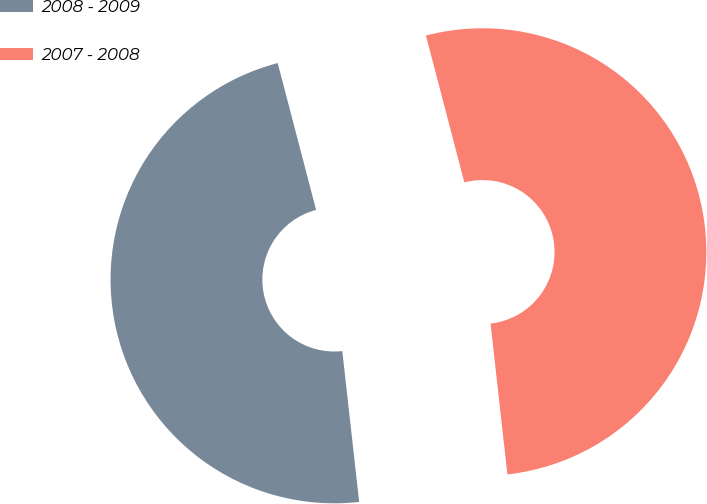Convert chart. <chart><loc_0><loc_0><loc_500><loc_500><pie_chart><fcel>2008 - 2009<fcel>2007 - 2008<nl><fcel>47.7%<fcel>52.3%<nl></chart> 